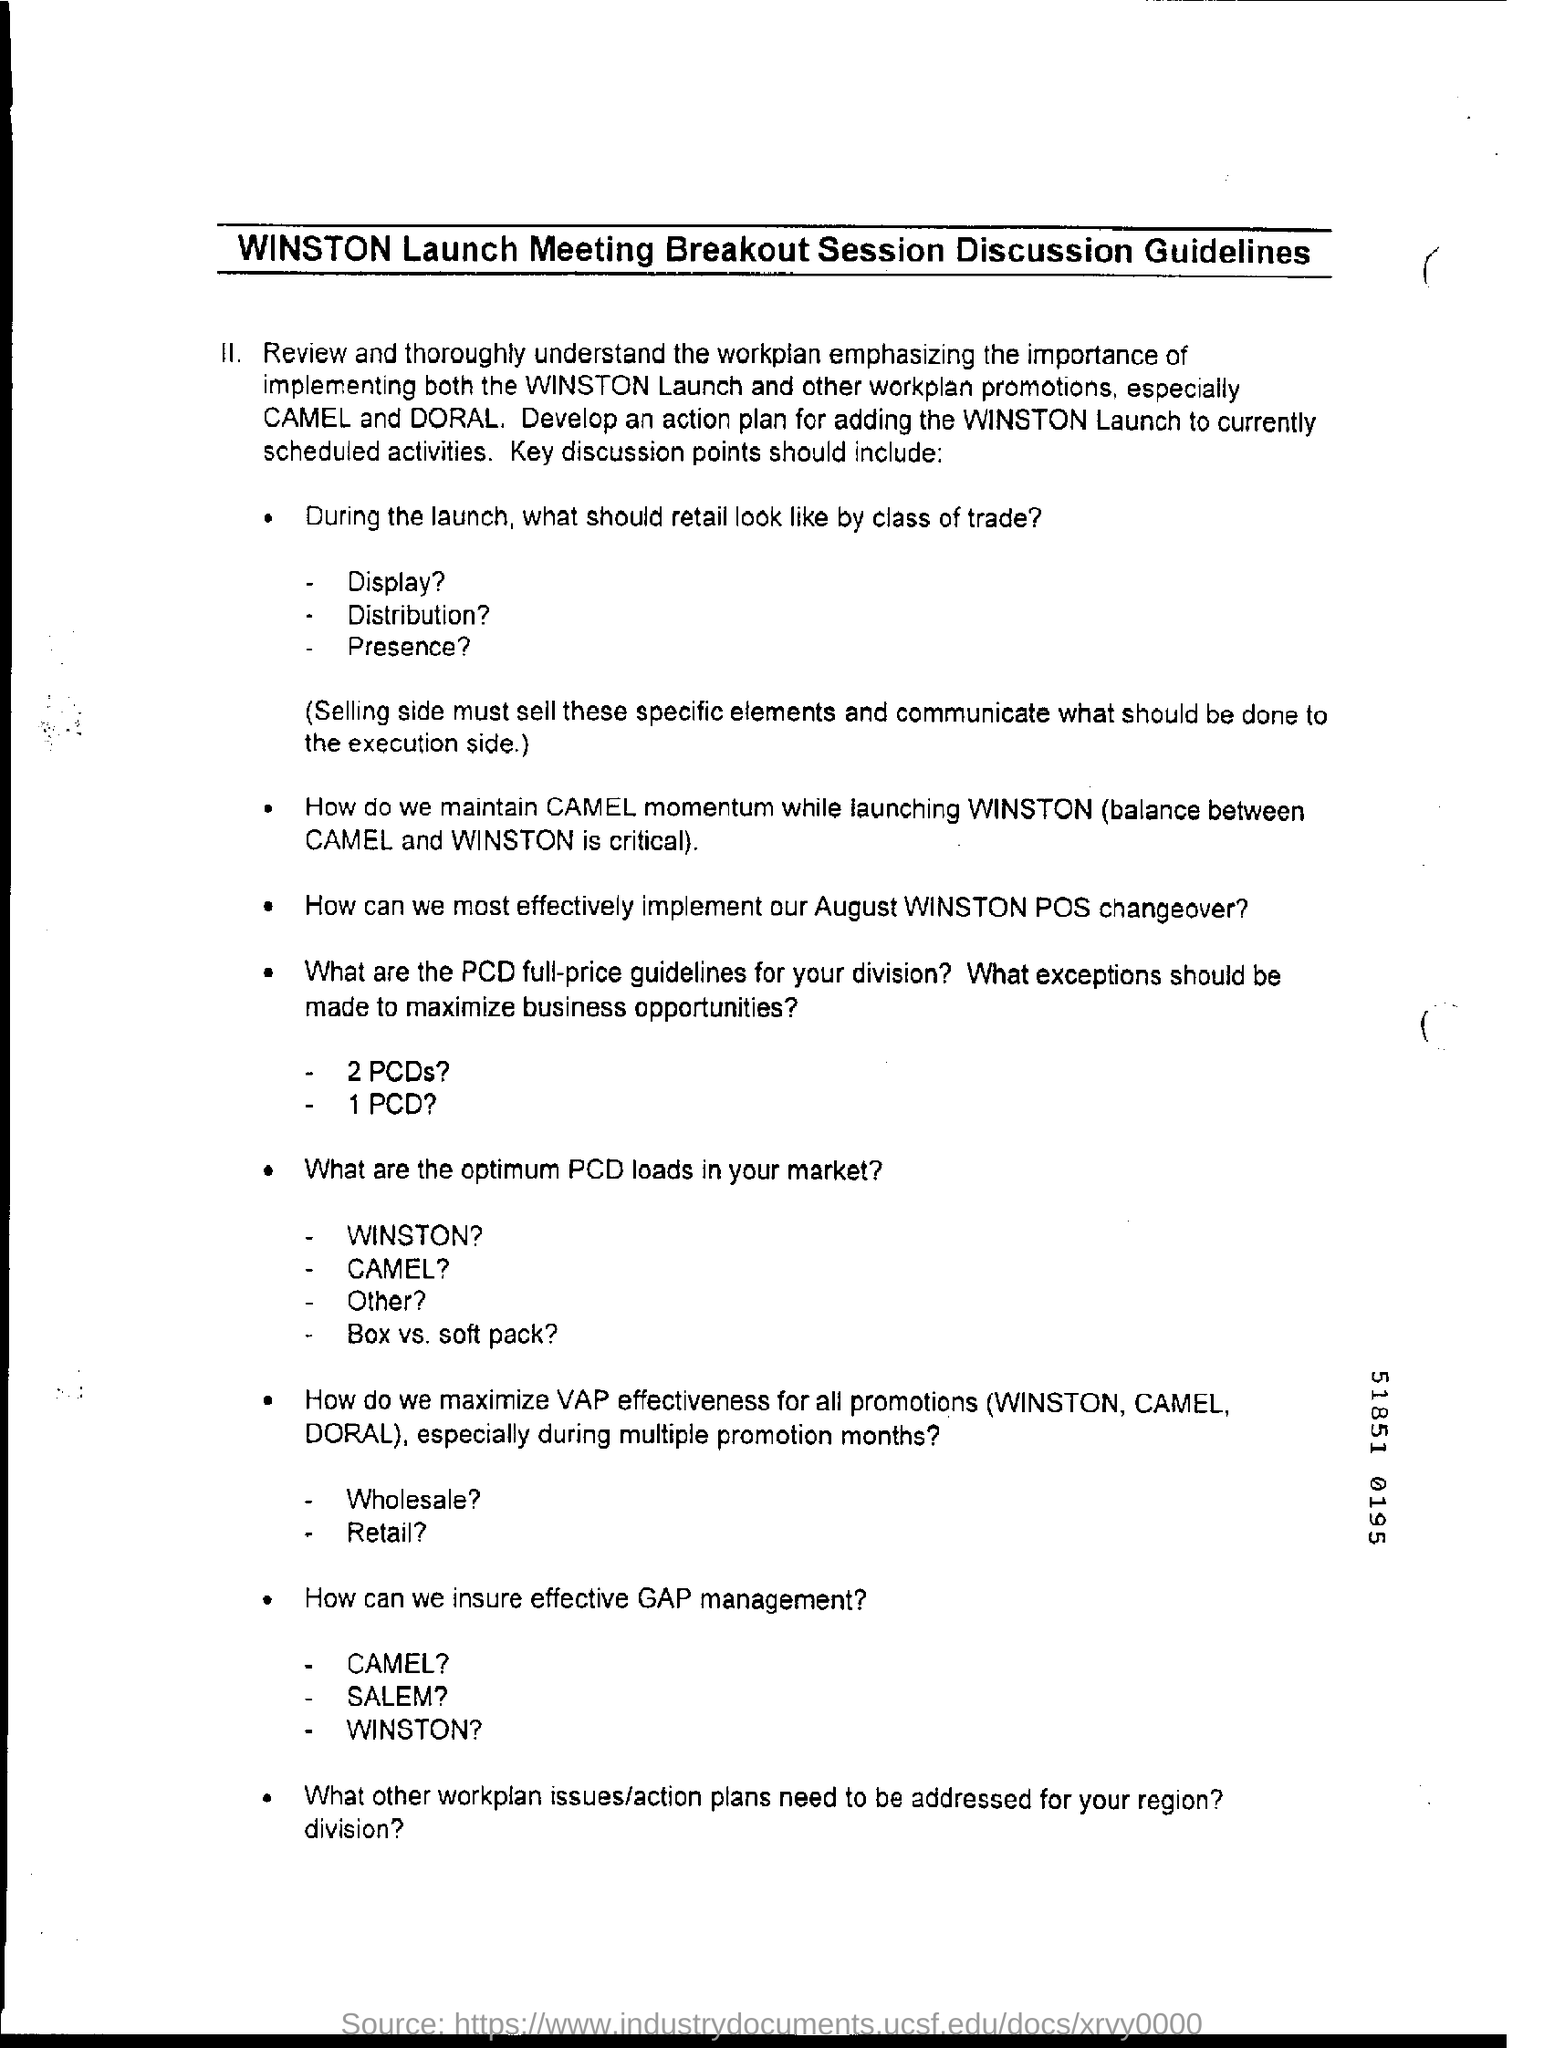Identify some key points in this picture. What are the other workplan promotions? Camel and Doral. 